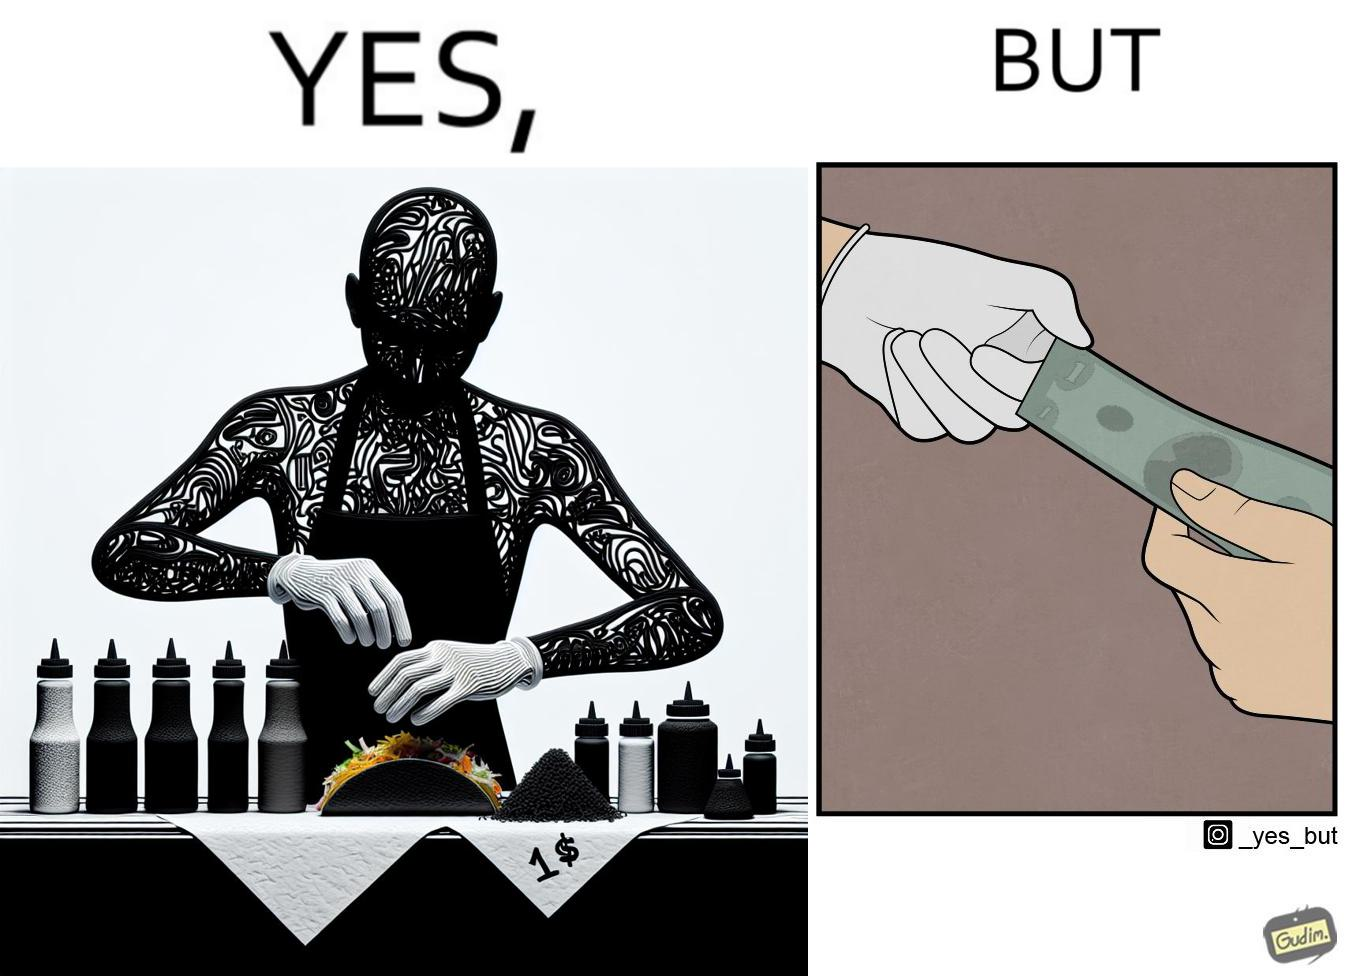Why is this image considered satirical? The image is satirical because the intention of wearing a glove while preparing food is to not let any germs and dirt from our hands get into the food, people do other tasks like collecting money from the customer wearing the same gloves and thus making the gloves themselves dirty. 